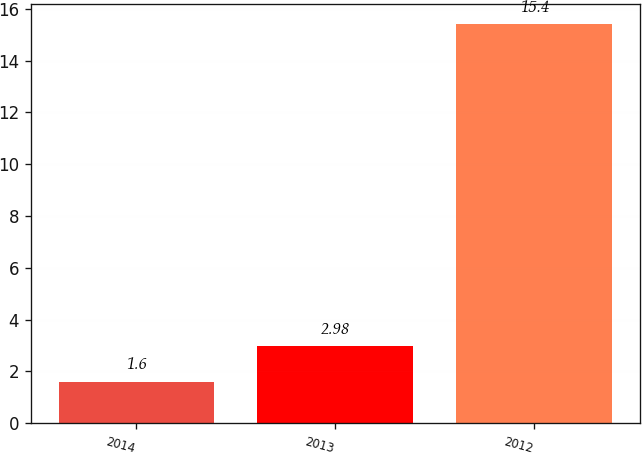<chart> <loc_0><loc_0><loc_500><loc_500><bar_chart><fcel>2014<fcel>2013<fcel>2012<nl><fcel>1.6<fcel>2.98<fcel>15.4<nl></chart> 